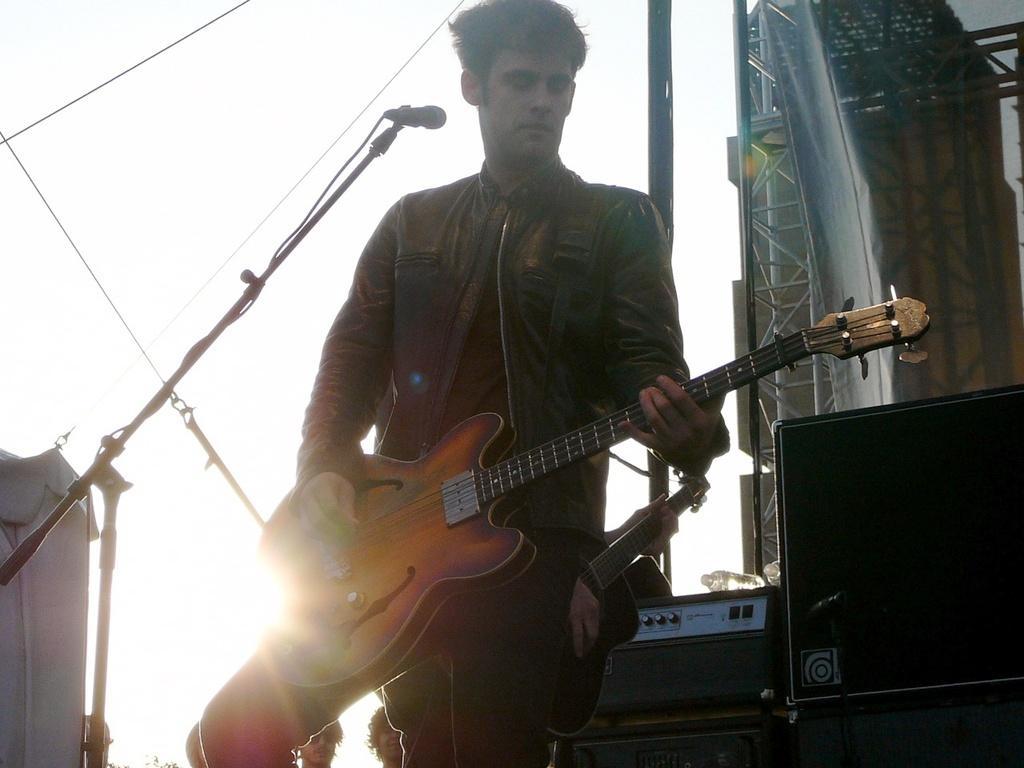Describe this image in one or two sentences. A man is standing and playing the guitar. 